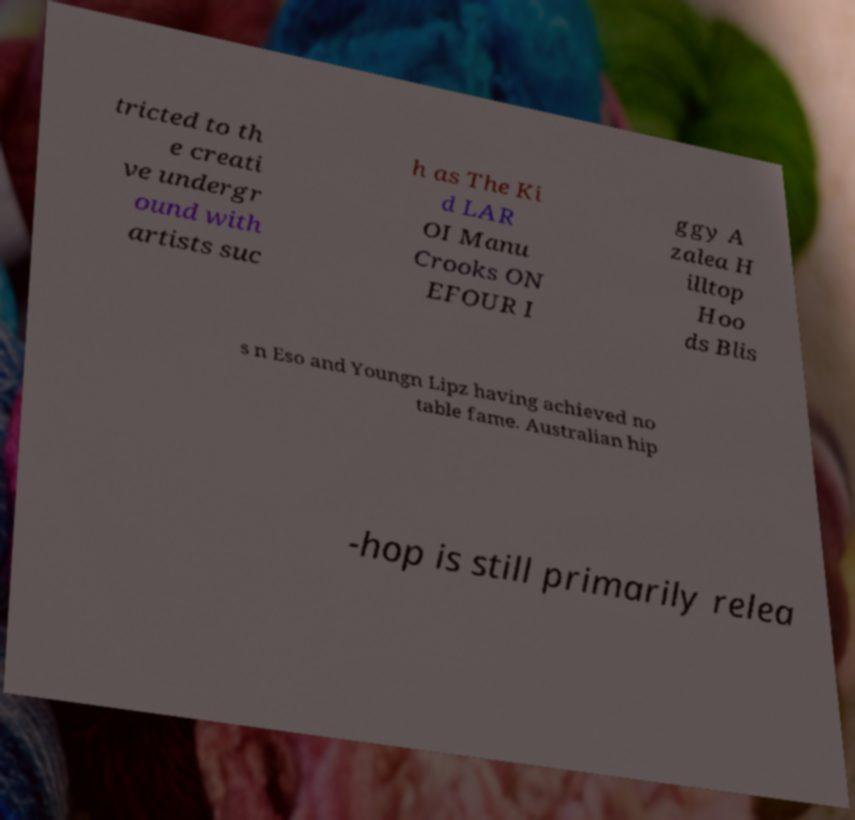What messages or text are displayed in this image? I need them in a readable, typed format. tricted to th e creati ve undergr ound with artists suc h as The Ki d LAR OI Manu Crooks ON EFOUR I ggy A zalea H illtop Hoo ds Blis s n Eso and Youngn Lipz having achieved no table fame. Australian hip -hop is still primarily relea 